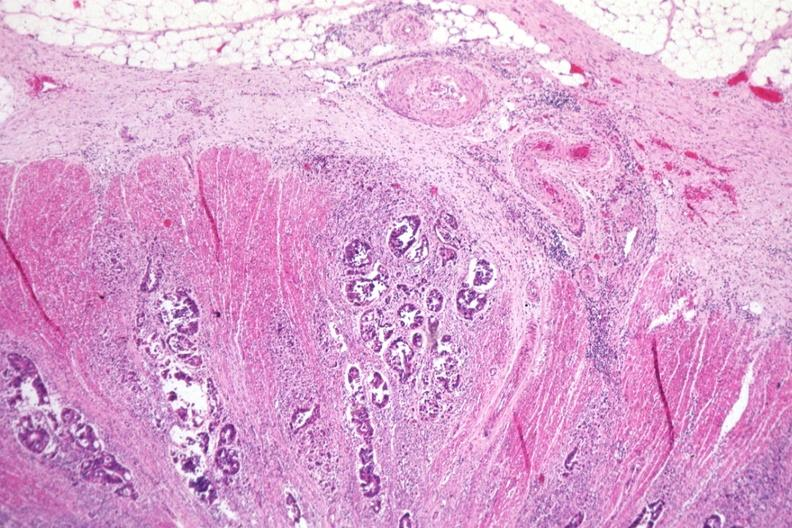what is present?
Answer the question using a single word or phrase. Colon 